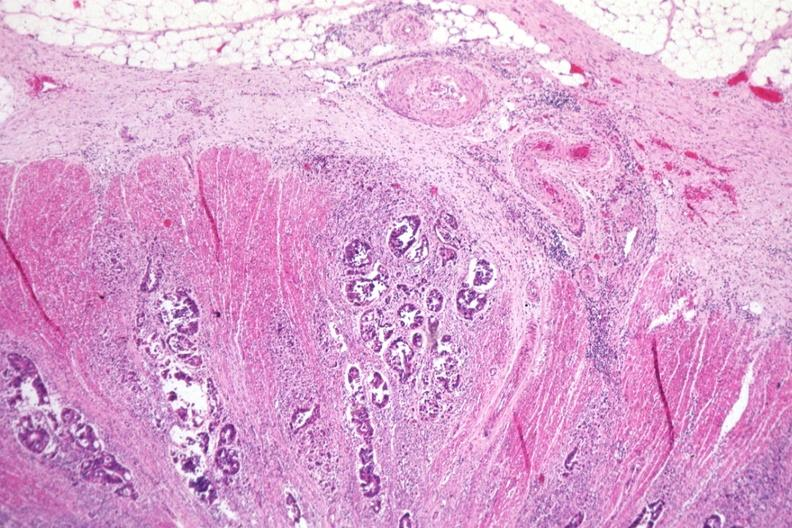what is present?
Answer the question using a single word or phrase. Colon 